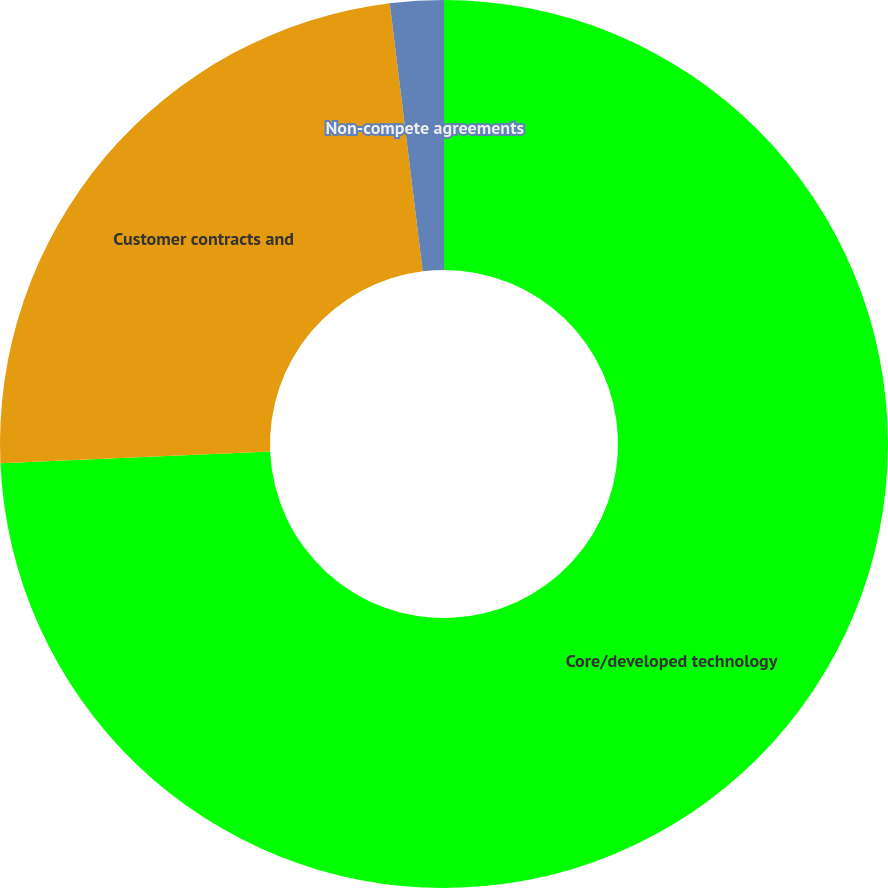Convert chart. <chart><loc_0><loc_0><loc_500><loc_500><pie_chart><fcel>Core/developed technology<fcel>Customer contracts and<fcel>Non-compete agreements<nl><fcel>74.32%<fcel>23.74%<fcel>1.95%<nl></chart> 